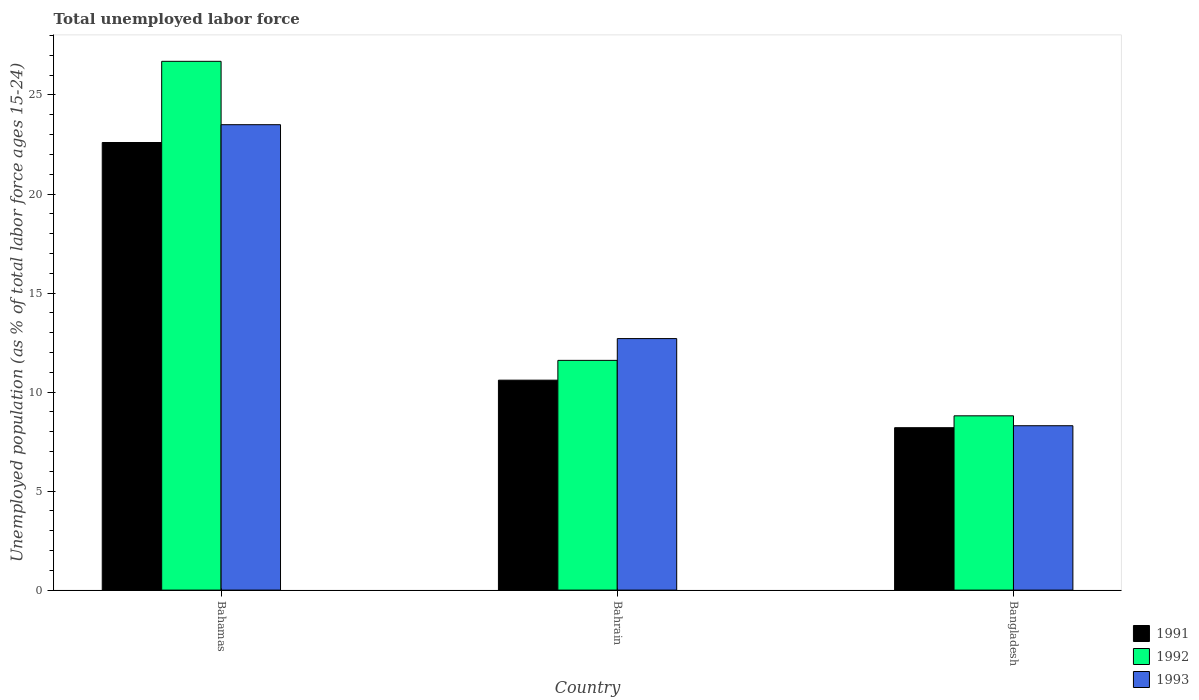How many different coloured bars are there?
Your answer should be very brief. 3. Are the number of bars on each tick of the X-axis equal?
Offer a terse response. Yes. How many bars are there on the 3rd tick from the right?
Your answer should be very brief. 3. What is the label of the 3rd group of bars from the left?
Keep it short and to the point. Bangladesh. What is the percentage of unemployed population in in 1992 in Bangladesh?
Ensure brevity in your answer.  8.8. Across all countries, what is the maximum percentage of unemployed population in in 1992?
Your answer should be compact. 26.7. Across all countries, what is the minimum percentage of unemployed population in in 1992?
Your answer should be compact. 8.8. In which country was the percentage of unemployed population in in 1992 maximum?
Keep it short and to the point. Bahamas. What is the total percentage of unemployed population in in 1992 in the graph?
Your answer should be very brief. 47.1. What is the difference between the percentage of unemployed population in in 1991 in Bahamas and that in Bahrain?
Your answer should be very brief. 12. What is the difference between the percentage of unemployed population in in 1993 in Bahamas and the percentage of unemployed population in in 1992 in Bahrain?
Keep it short and to the point. 11.9. What is the average percentage of unemployed population in in 1992 per country?
Ensure brevity in your answer.  15.7. What is the difference between the percentage of unemployed population in of/in 1992 and percentage of unemployed population in of/in 1991 in Bahamas?
Provide a short and direct response. 4.1. In how many countries, is the percentage of unemployed population in in 1991 greater than 16 %?
Ensure brevity in your answer.  1. What is the ratio of the percentage of unemployed population in in 1992 in Bahrain to that in Bangladesh?
Make the answer very short. 1.32. Is the percentage of unemployed population in in 1993 in Bahamas less than that in Bahrain?
Your response must be concise. No. Is the difference between the percentage of unemployed population in in 1992 in Bahrain and Bangladesh greater than the difference between the percentage of unemployed population in in 1991 in Bahrain and Bangladesh?
Ensure brevity in your answer.  Yes. What is the difference between the highest and the second highest percentage of unemployed population in in 1991?
Offer a very short reply. -2.4. What is the difference between the highest and the lowest percentage of unemployed population in in 1993?
Offer a terse response. 15.2. Is the sum of the percentage of unemployed population in in 1992 in Bahrain and Bangladesh greater than the maximum percentage of unemployed population in in 1993 across all countries?
Ensure brevity in your answer.  No. What does the 2nd bar from the left in Bahrain represents?
Ensure brevity in your answer.  1992. What does the 1st bar from the right in Bahrain represents?
Offer a very short reply. 1993. How many countries are there in the graph?
Keep it short and to the point. 3. Are the values on the major ticks of Y-axis written in scientific E-notation?
Your answer should be compact. No. Does the graph contain grids?
Your response must be concise. No. What is the title of the graph?
Make the answer very short. Total unemployed labor force. What is the label or title of the X-axis?
Offer a very short reply. Country. What is the label or title of the Y-axis?
Your response must be concise. Unemployed population (as % of total labor force ages 15-24). What is the Unemployed population (as % of total labor force ages 15-24) of 1991 in Bahamas?
Provide a short and direct response. 22.6. What is the Unemployed population (as % of total labor force ages 15-24) of 1992 in Bahamas?
Your answer should be compact. 26.7. What is the Unemployed population (as % of total labor force ages 15-24) of 1993 in Bahamas?
Your answer should be compact. 23.5. What is the Unemployed population (as % of total labor force ages 15-24) of 1991 in Bahrain?
Ensure brevity in your answer.  10.6. What is the Unemployed population (as % of total labor force ages 15-24) of 1992 in Bahrain?
Provide a short and direct response. 11.6. What is the Unemployed population (as % of total labor force ages 15-24) of 1993 in Bahrain?
Your answer should be very brief. 12.7. What is the Unemployed population (as % of total labor force ages 15-24) of 1991 in Bangladesh?
Offer a very short reply. 8.2. What is the Unemployed population (as % of total labor force ages 15-24) of 1992 in Bangladesh?
Offer a terse response. 8.8. What is the Unemployed population (as % of total labor force ages 15-24) of 1993 in Bangladesh?
Your answer should be very brief. 8.3. Across all countries, what is the maximum Unemployed population (as % of total labor force ages 15-24) of 1991?
Keep it short and to the point. 22.6. Across all countries, what is the maximum Unemployed population (as % of total labor force ages 15-24) of 1992?
Provide a succinct answer. 26.7. Across all countries, what is the maximum Unemployed population (as % of total labor force ages 15-24) in 1993?
Offer a terse response. 23.5. Across all countries, what is the minimum Unemployed population (as % of total labor force ages 15-24) in 1991?
Make the answer very short. 8.2. Across all countries, what is the minimum Unemployed population (as % of total labor force ages 15-24) in 1992?
Your answer should be very brief. 8.8. Across all countries, what is the minimum Unemployed population (as % of total labor force ages 15-24) in 1993?
Provide a succinct answer. 8.3. What is the total Unemployed population (as % of total labor force ages 15-24) in 1991 in the graph?
Your answer should be compact. 41.4. What is the total Unemployed population (as % of total labor force ages 15-24) in 1992 in the graph?
Your answer should be compact. 47.1. What is the total Unemployed population (as % of total labor force ages 15-24) in 1993 in the graph?
Ensure brevity in your answer.  44.5. What is the difference between the Unemployed population (as % of total labor force ages 15-24) in 1991 in Bahamas and that in Bahrain?
Keep it short and to the point. 12. What is the difference between the Unemployed population (as % of total labor force ages 15-24) in 1993 in Bahrain and that in Bangladesh?
Offer a terse response. 4.4. What is the difference between the Unemployed population (as % of total labor force ages 15-24) of 1991 in Bahamas and the Unemployed population (as % of total labor force ages 15-24) of 1992 in Bahrain?
Make the answer very short. 11. What is the difference between the Unemployed population (as % of total labor force ages 15-24) of 1992 in Bahamas and the Unemployed population (as % of total labor force ages 15-24) of 1993 in Bahrain?
Keep it short and to the point. 14. What is the difference between the Unemployed population (as % of total labor force ages 15-24) in 1991 in Bahamas and the Unemployed population (as % of total labor force ages 15-24) in 1992 in Bangladesh?
Make the answer very short. 13.8. What is the difference between the Unemployed population (as % of total labor force ages 15-24) of 1992 in Bahamas and the Unemployed population (as % of total labor force ages 15-24) of 1993 in Bangladesh?
Your answer should be compact. 18.4. What is the difference between the Unemployed population (as % of total labor force ages 15-24) of 1991 in Bahrain and the Unemployed population (as % of total labor force ages 15-24) of 1992 in Bangladesh?
Ensure brevity in your answer.  1.8. What is the difference between the Unemployed population (as % of total labor force ages 15-24) of 1991 in Bahrain and the Unemployed population (as % of total labor force ages 15-24) of 1993 in Bangladesh?
Provide a succinct answer. 2.3. What is the difference between the Unemployed population (as % of total labor force ages 15-24) of 1992 in Bahrain and the Unemployed population (as % of total labor force ages 15-24) of 1993 in Bangladesh?
Provide a short and direct response. 3.3. What is the average Unemployed population (as % of total labor force ages 15-24) of 1991 per country?
Provide a short and direct response. 13.8. What is the average Unemployed population (as % of total labor force ages 15-24) of 1992 per country?
Provide a short and direct response. 15.7. What is the average Unemployed population (as % of total labor force ages 15-24) of 1993 per country?
Give a very brief answer. 14.83. What is the difference between the Unemployed population (as % of total labor force ages 15-24) in 1991 and Unemployed population (as % of total labor force ages 15-24) in 1993 in Bahamas?
Your response must be concise. -0.9. What is the difference between the Unemployed population (as % of total labor force ages 15-24) in 1992 and Unemployed population (as % of total labor force ages 15-24) in 1993 in Bahamas?
Your answer should be very brief. 3.2. What is the difference between the Unemployed population (as % of total labor force ages 15-24) in 1991 and Unemployed population (as % of total labor force ages 15-24) in 1992 in Bahrain?
Keep it short and to the point. -1. What is the difference between the Unemployed population (as % of total labor force ages 15-24) in 1991 and Unemployed population (as % of total labor force ages 15-24) in 1993 in Bahrain?
Your answer should be very brief. -2.1. What is the difference between the Unemployed population (as % of total labor force ages 15-24) in 1991 and Unemployed population (as % of total labor force ages 15-24) in 1992 in Bangladesh?
Provide a short and direct response. -0.6. What is the difference between the Unemployed population (as % of total labor force ages 15-24) of 1991 and Unemployed population (as % of total labor force ages 15-24) of 1993 in Bangladesh?
Your answer should be compact. -0.1. What is the ratio of the Unemployed population (as % of total labor force ages 15-24) in 1991 in Bahamas to that in Bahrain?
Give a very brief answer. 2.13. What is the ratio of the Unemployed population (as % of total labor force ages 15-24) of 1992 in Bahamas to that in Bahrain?
Your answer should be very brief. 2.3. What is the ratio of the Unemployed population (as % of total labor force ages 15-24) in 1993 in Bahamas to that in Bahrain?
Offer a terse response. 1.85. What is the ratio of the Unemployed population (as % of total labor force ages 15-24) in 1991 in Bahamas to that in Bangladesh?
Your answer should be very brief. 2.76. What is the ratio of the Unemployed population (as % of total labor force ages 15-24) of 1992 in Bahamas to that in Bangladesh?
Offer a terse response. 3.03. What is the ratio of the Unemployed population (as % of total labor force ages 15-24) of 1993 in Bahamas to that in Bangladesh?
Your answer should be compact. 2.83. What is the ratio of the Unemployed population (as % of total labor force ages 15-24) of 1991 in Bahrain to that in Bangladesh?
Offer a terse response. 1.29. What is the ratio of the Unemployed population (as % of total labor force ages 15-24) in 1992 in Bahrain to that in Bangladesh?
Provide a short and direct response. 1.32. What is the ratio of the Unemployed population (as % of total labor force ages 15-24) of 1993 in Bahrain to that in Bangladesh?
Your response must be concise. 1.53. What is the difference between the highest and the lowest Unemployed population (as % of total labor force ages 15-24) of 1991?
Offer a very short reply. 14.4. What is the difference between the highest and the lowest Unemployed population (as % of total labor force ages 15-24) in 1992?
Ensure brevity in your answer.  17.9. 